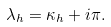Convert formula to latex. <formula><loc_0><loc_0><loc_500><loc_500>\lambda _ { h } = \kappa _ { h } + i \pi .</formula> 